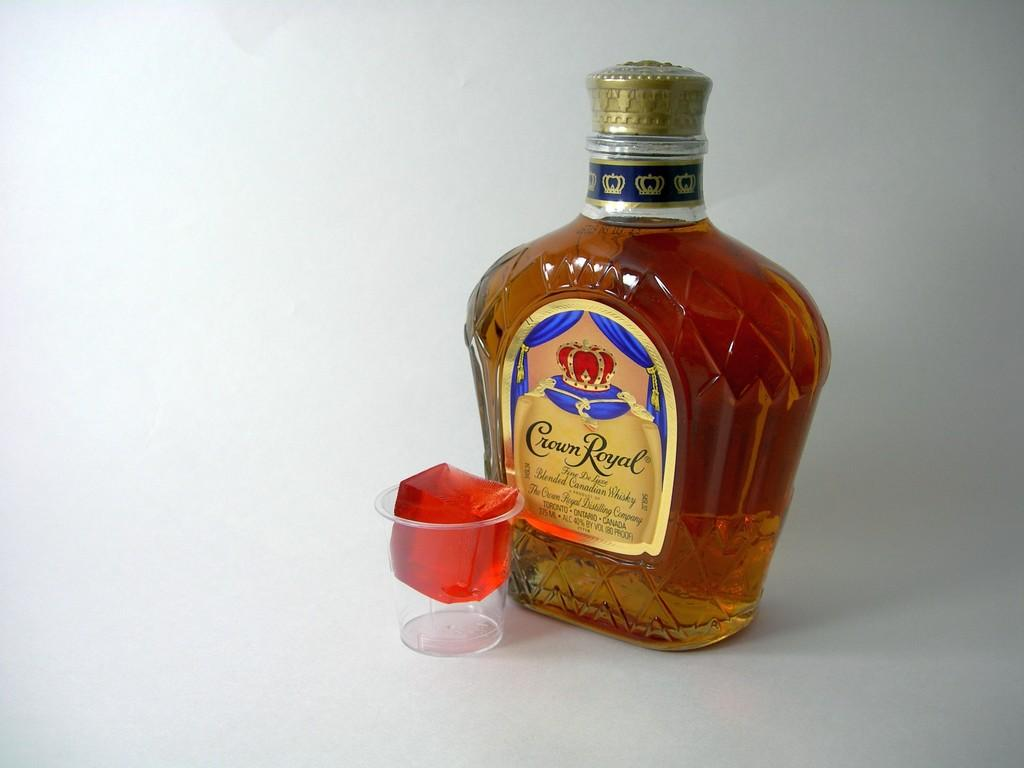<image>
Write a terse but informative summary of the picture. A red square of gelatin is in a small glass in front of a Crown Royal bottle. 